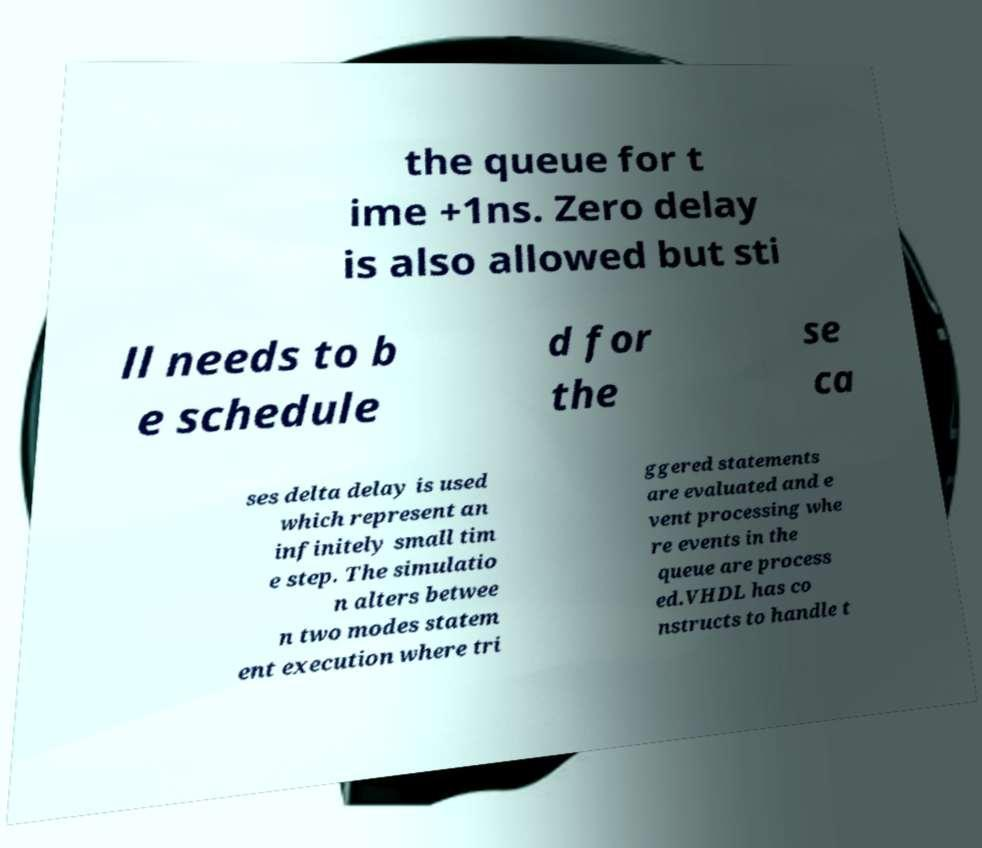Could you assist in decoding the text presented in this image and type it out clearly? the queue for t ime +1ns. Zero delay is also allowed but sti ll needs to b e schedule d for the se ca ses delta delay is used which represent an infinitely small tim e step. The simulatio n alters betwee n two modes statem ent execution where tri ggered statements are evaluated and e vent processing whe re events in the queue are process ed.VHDL has co nstructs to handle t 